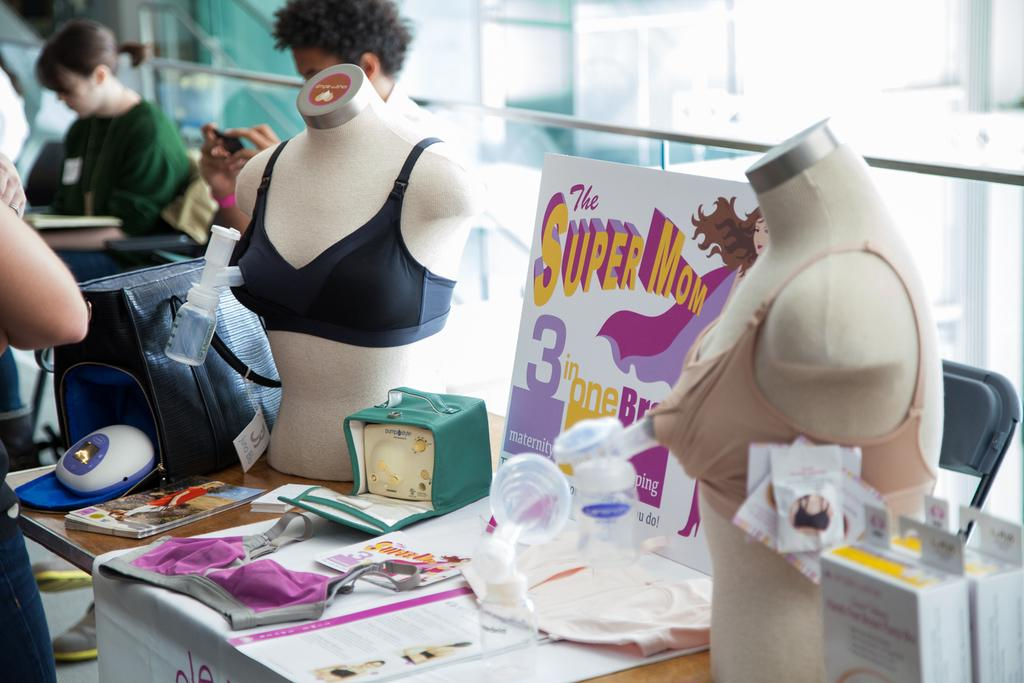How many people are in the image? There are two persons in the image. What can be seen on the table in the image? There are objects on the table in the image. What type of furniture is present in the image? There is a chair in the image. What is written or displayed on the board in the image? There is a board with text in the image. What type of clothing is visible in the image? There are clothes visible in the image. Where is the airport located in the image? There is no airport present in the image. What type of toys can be seen on the table in the image? There are no toys visible on the table in the image. 